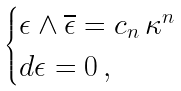Convert formula to latex. <formula><loc_0><loc_0><loc_500><loc_500>\begin{cases} \epsilon \wedge \overline { \epsilon } = c _ { n } \, \kappa ^ { n } \\ d \epsilon = 0 \, , \end{cases}</formula> 